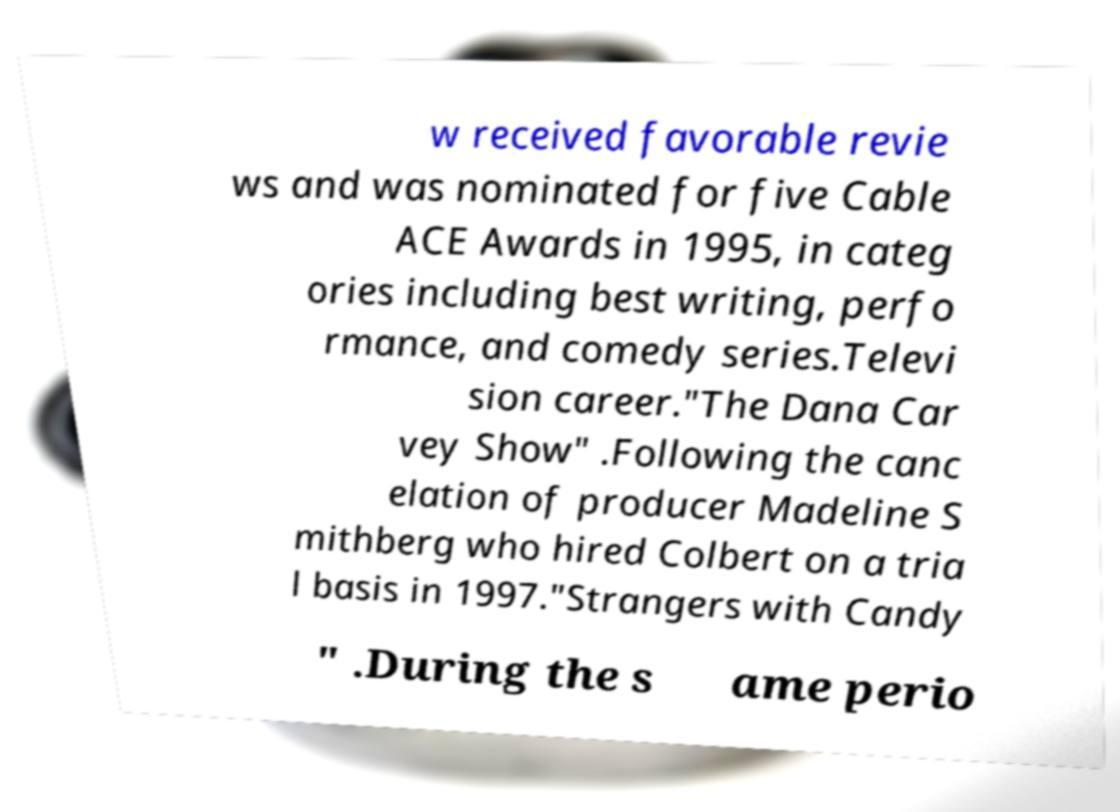Can you read and provide the text displayed in the image?This photo seems to have some interesting text. Can you extract and type it out for me? w received favorable revie ws and was nominated for five Cable ACE Awards in 1995, in categ ories including best writing, perfo rmance, and comedy series.Televi sion career."The Dana Car vey Show" .Following the canc elation of producer Madeline S mithberg who hired Colbert on a tria l basis in 1997."Strangers with Candy " .During the s ame perio 